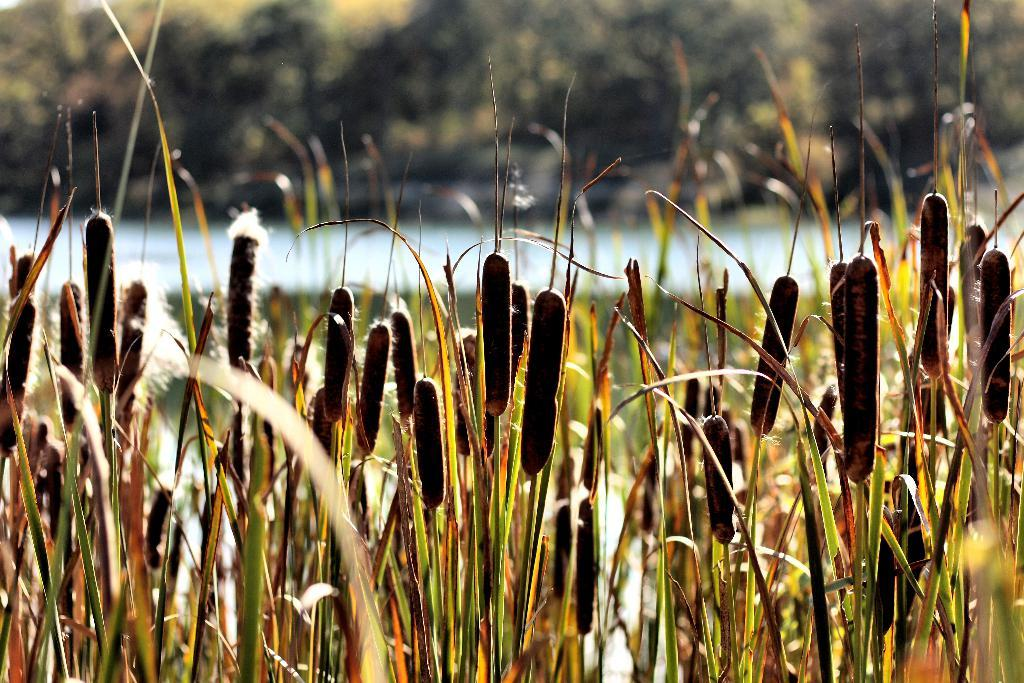What type of living organisms are in the image? There are plants in the image. What color are the plants in the image? The plants are green in color. Can you describe the background of the image? The background of the image is blurred. What type of earth can be seen in the image? There is no earth visible in the image; it features plants and a blurred background. What selection of baby items can be seen in the image? There is no selection of baby items present in the image. 